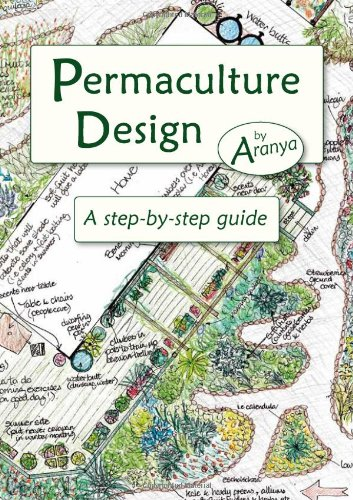Can you explain what permaculture design is? Permaculture design is a system of principles and practices aimed at creating sustainable and self-sufficient agricultural landscapes that work in harmony with natural ecosystems. 